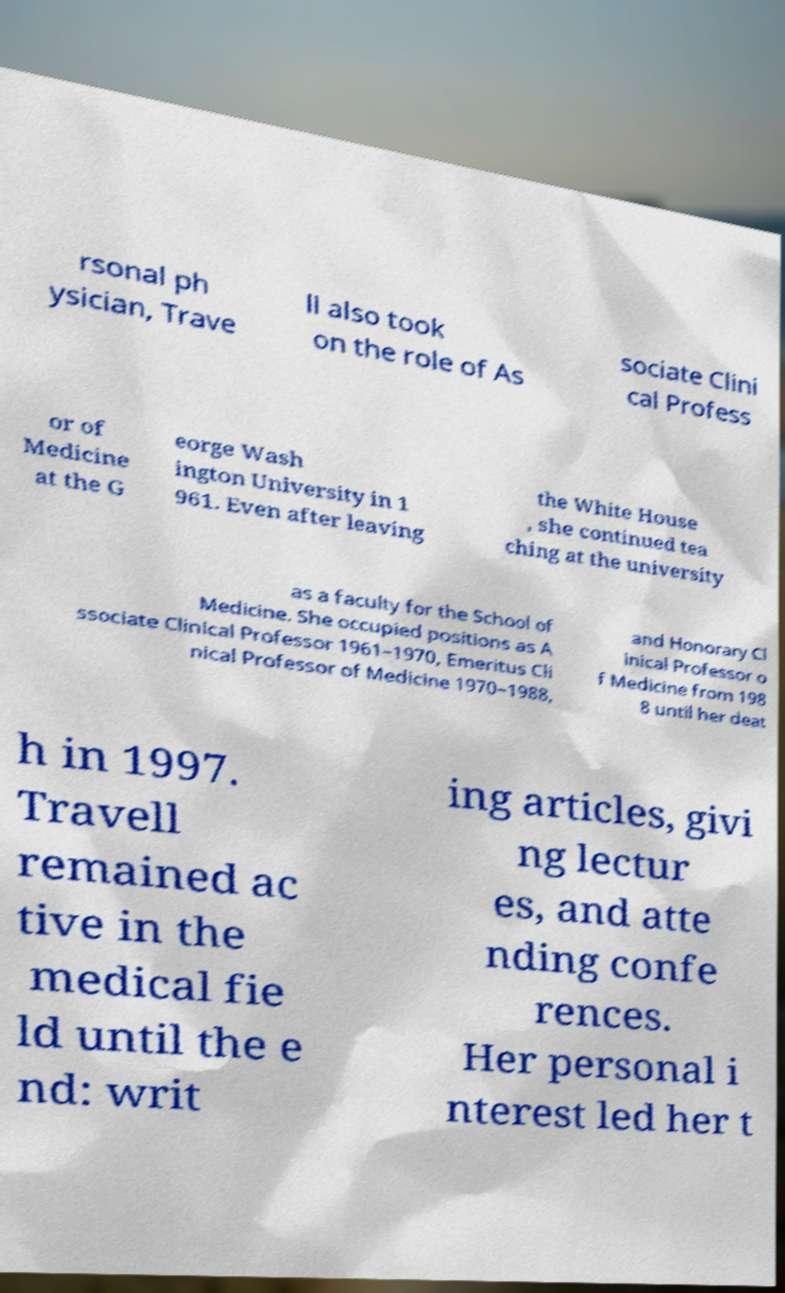Can you accurately transcribe the text from the provided image for me? rsonal ph ysician, Trave ll also took on the role of As sociate Clini cal Profess or of Medicine at the G eorge Wash ington University in 1 961. Even after leaving the White House , she continued tea ching at the university as a faculty for the School of Medicine. She occupied positions as A ssociate Clinical Professor 1961–1970, Emeritus Cli nical Professor of Medicine 1970–1988, and Honorary Cl inical Professor o f Medicine from 198 8 until her deat h in 1997. Travell remained ac tive in the medical fie ld until the e nd: writ ing articles, givi ng lectur es, and atte nding confe rences. Her personal i nterest led her t 